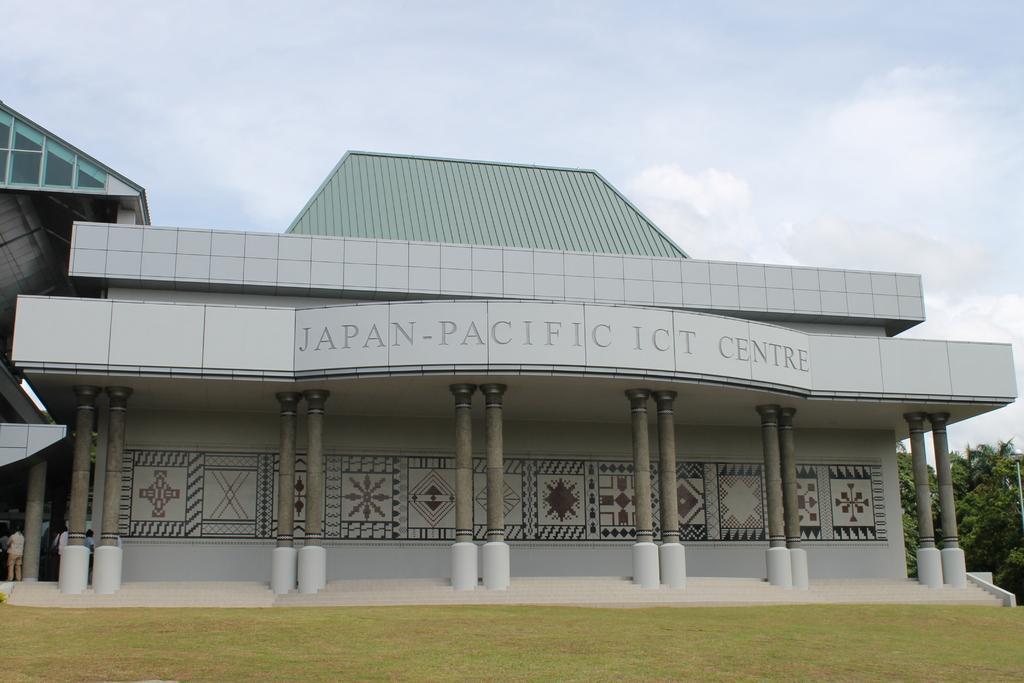How would you summarize this image in a sentence or two? It is a building in grey color, in the middle there is the name on it. At the top it is the cloudy sky, on the right side there are trees in this image. 